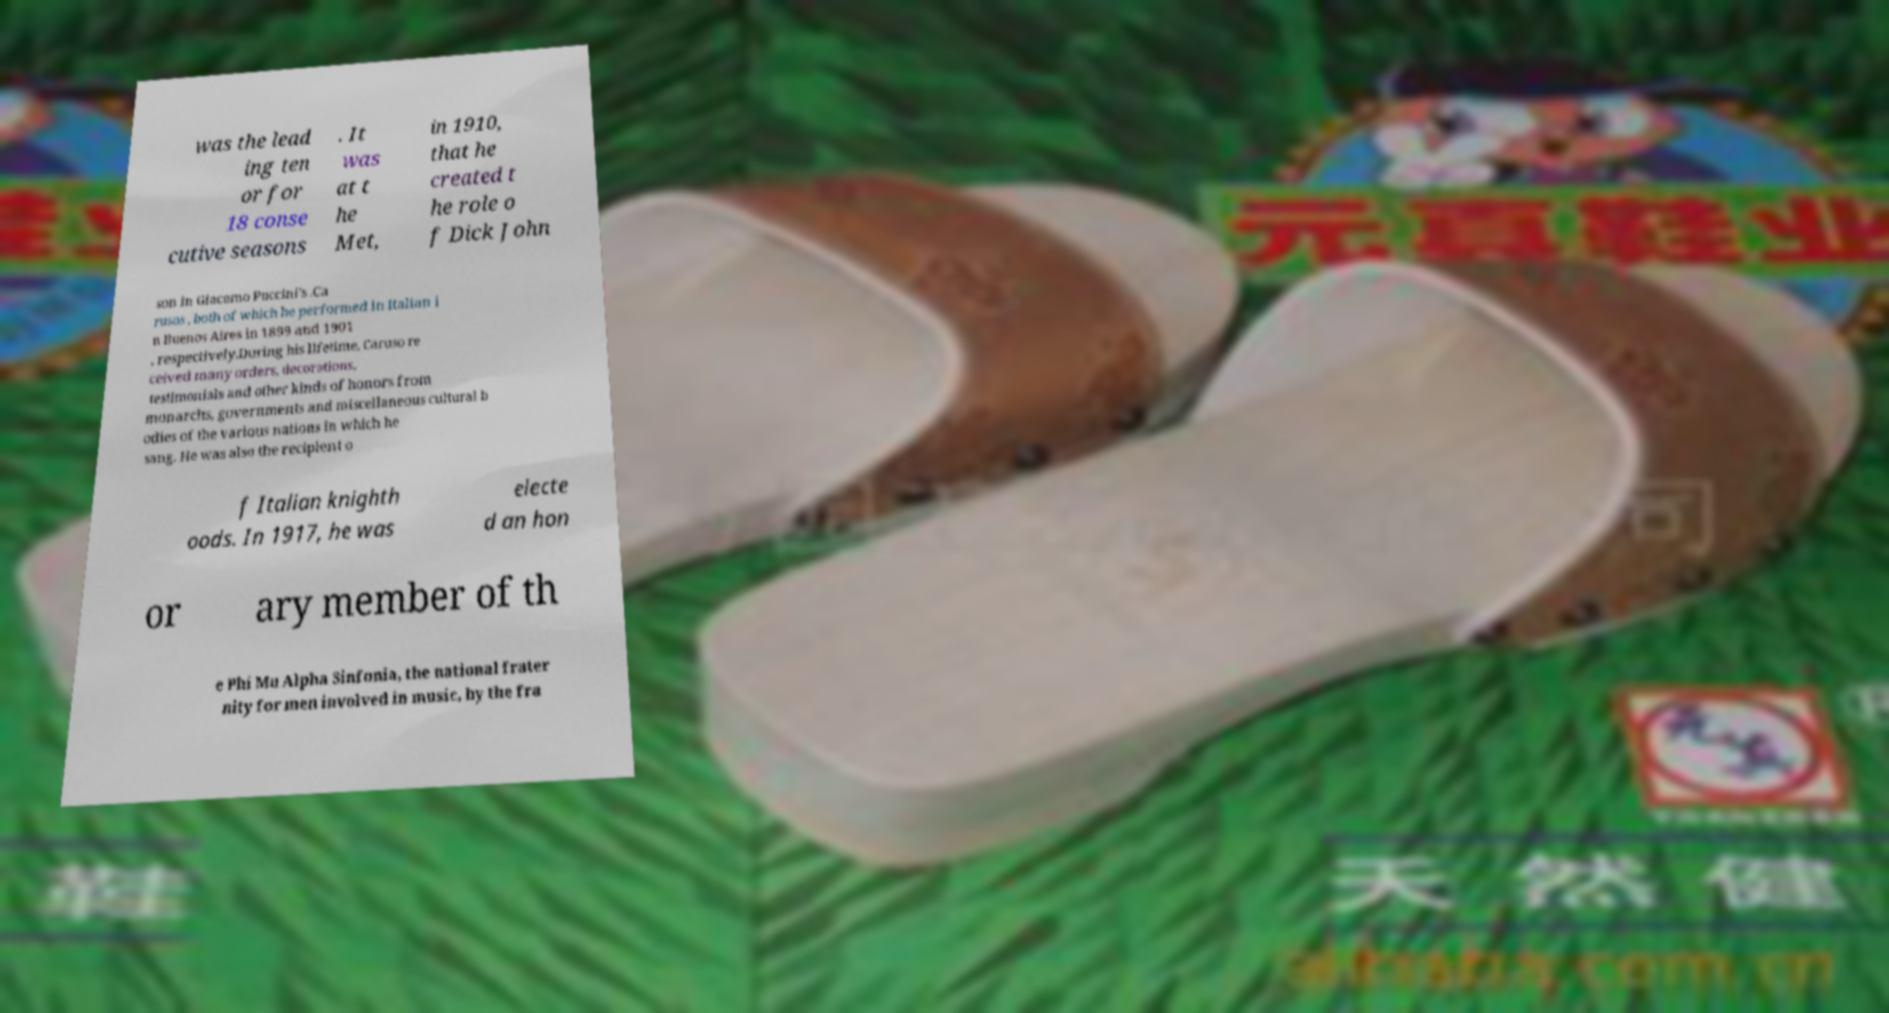Could you assist in decoding the text presented in this image and type it out clearly? was the lead ing ten or for 18 conse cutive seasons . It was at t he Met, in 1910, that he created t he role o f Dick John son in Giacomo Puccini's .Ca rusos , both of which he performed in Italian i n Buenos Aires in 1899 and 1901 , respectively.During his lifetime, Caruso re ceived many orders, decorations, testimonials and other kinds of honors from monarchs, governments and miscellaneous cultural b odies of the various nations in which he sang. He was also the recipient o f Italian knighth oods. In 1917, he was electe d an hon or ary member of th e Phi Mu Alpha Sinfonia, the national frater nity for men involved in music, by the fra 